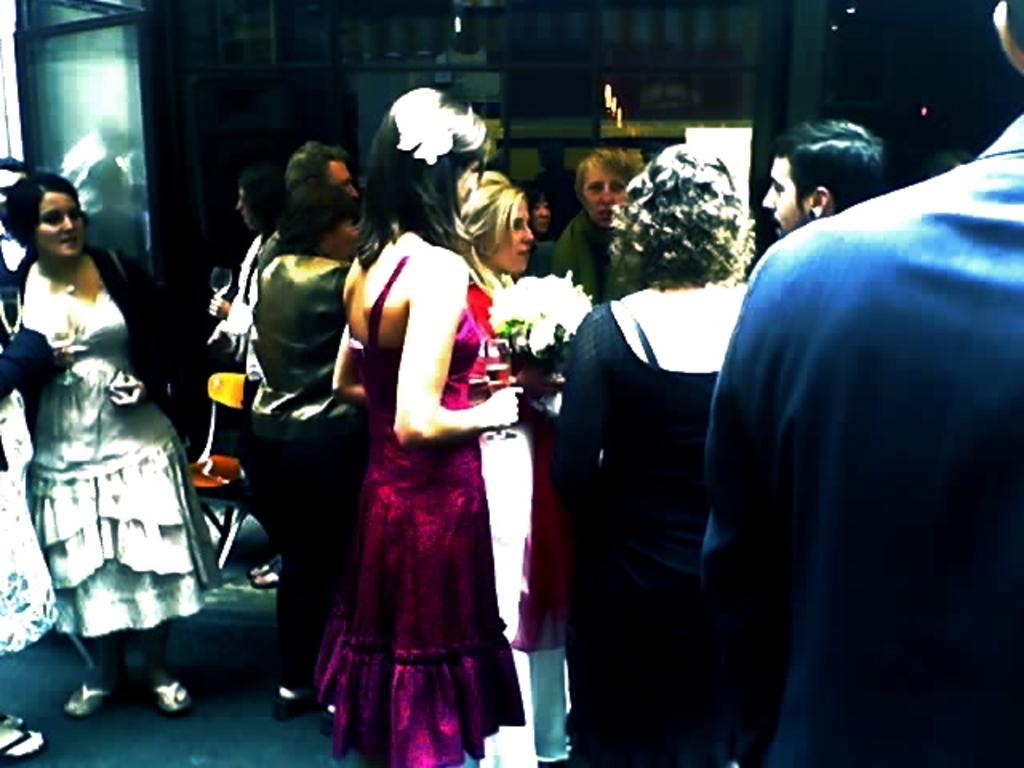Can you describe this image briefly? This is an edited image, we can see a group of people standing on the floor and a woman is holding a flower bouquet. On the floor there is a chair. Behind the people, it looks like a wall. 